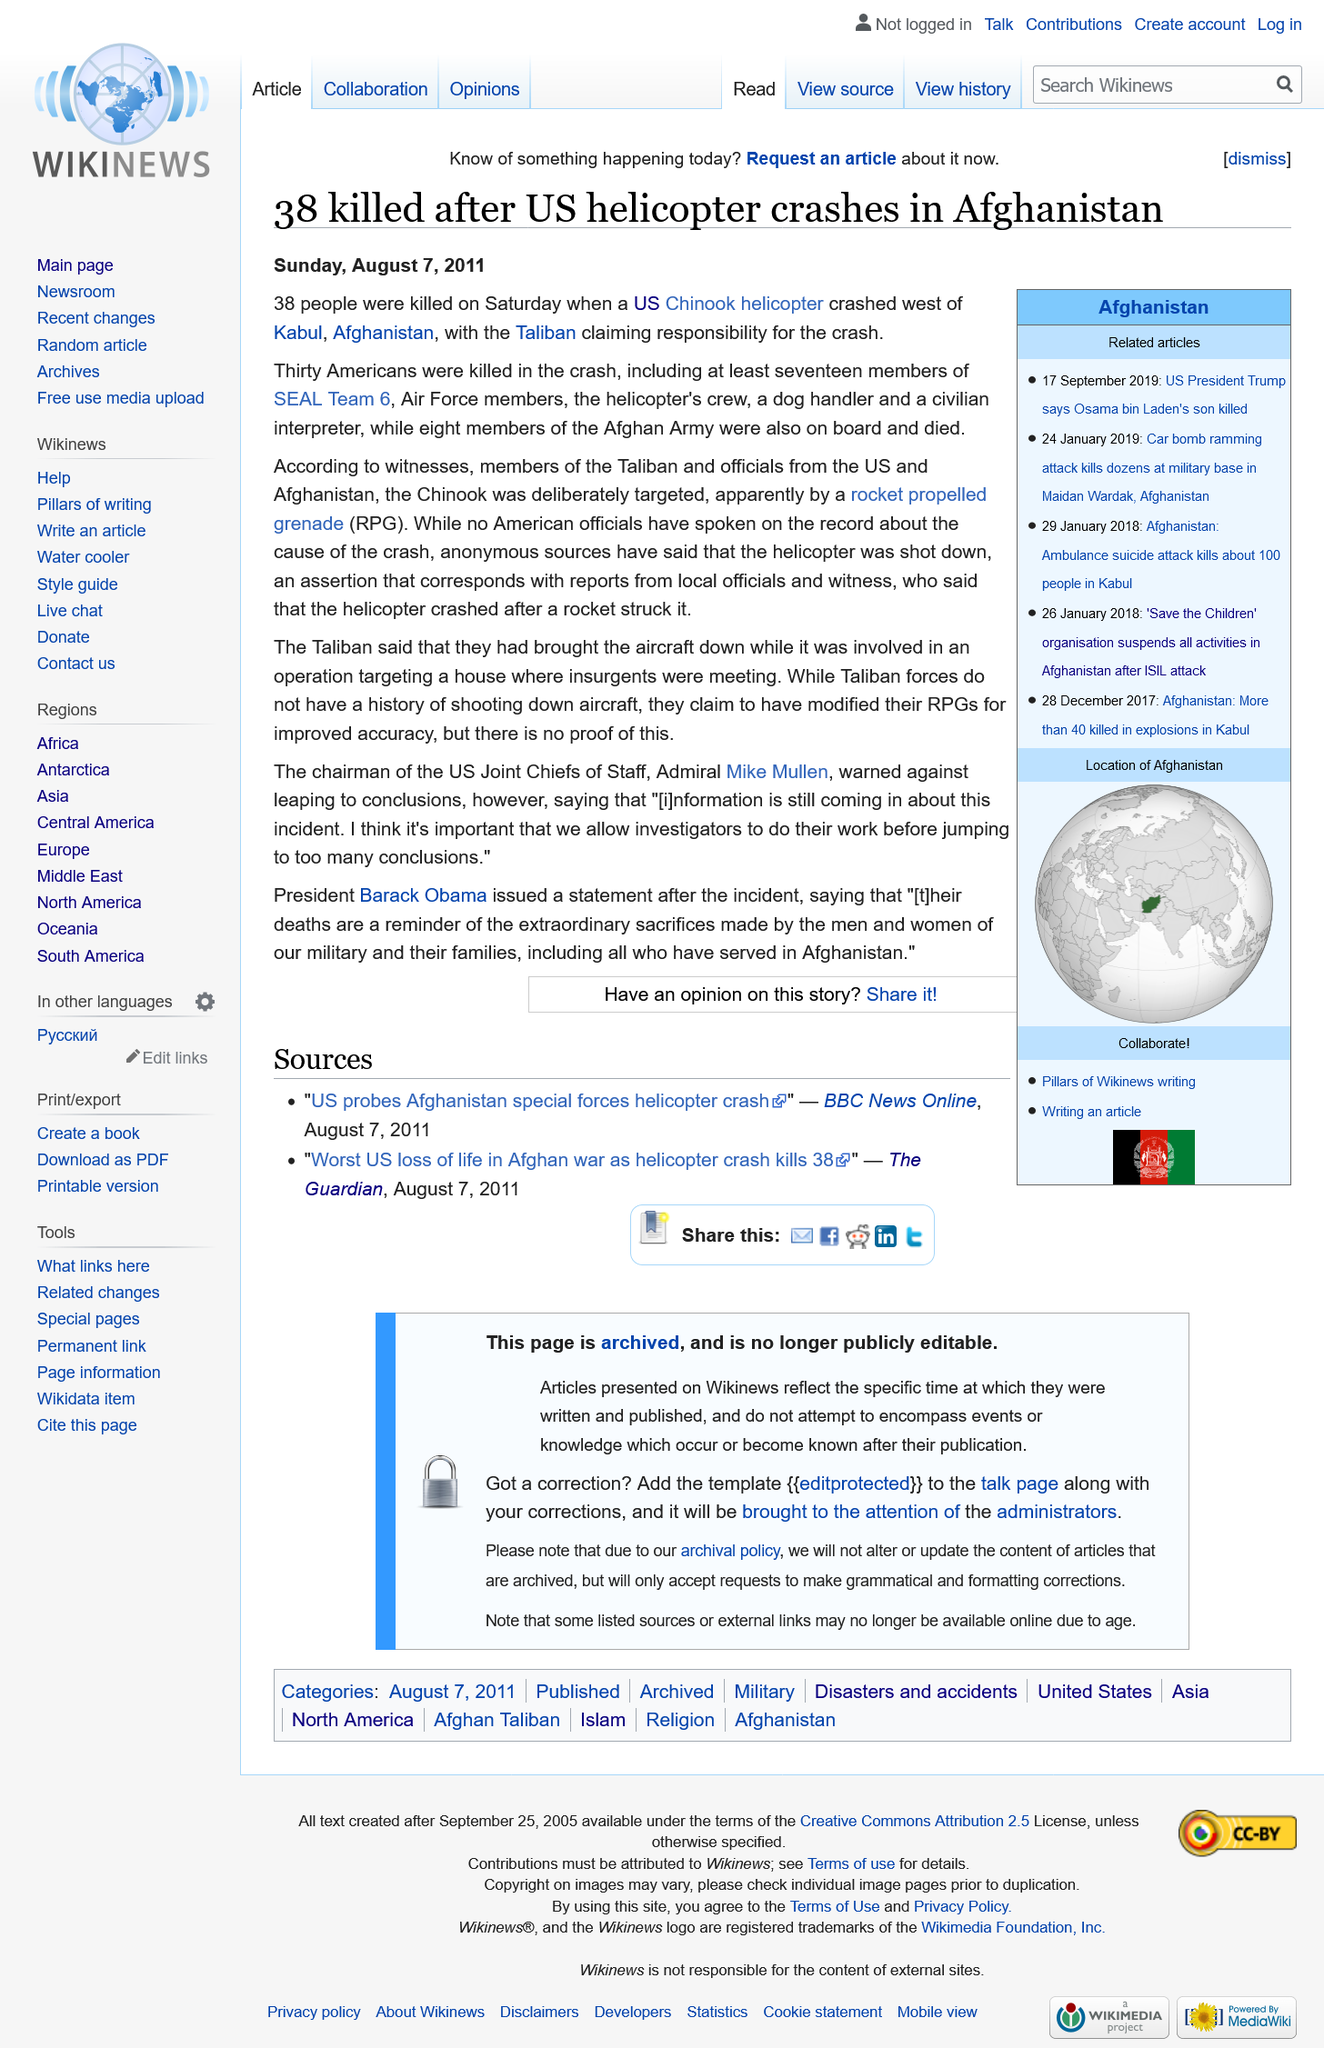Highlight a few significant elements in this photo. Eight members of the Afghan Army lost their lives in a tragic helicopter crash in Afghanistan. The Taliban is responsible for the helicopter crash. On January 31, a helicopter was reportedly hit by an RPG, resulting in the death of 38 people. 